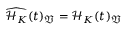Convert formula to latex. <formula><loc_0><loc_0><loc_500><loc_500>\widehat { \mathcal { H } _ { K } } ( t ) _ { \mathfrak { V } } = \mathcal { H } _ { K } ( t ) _ { \mathfrak { V } }</formula> 